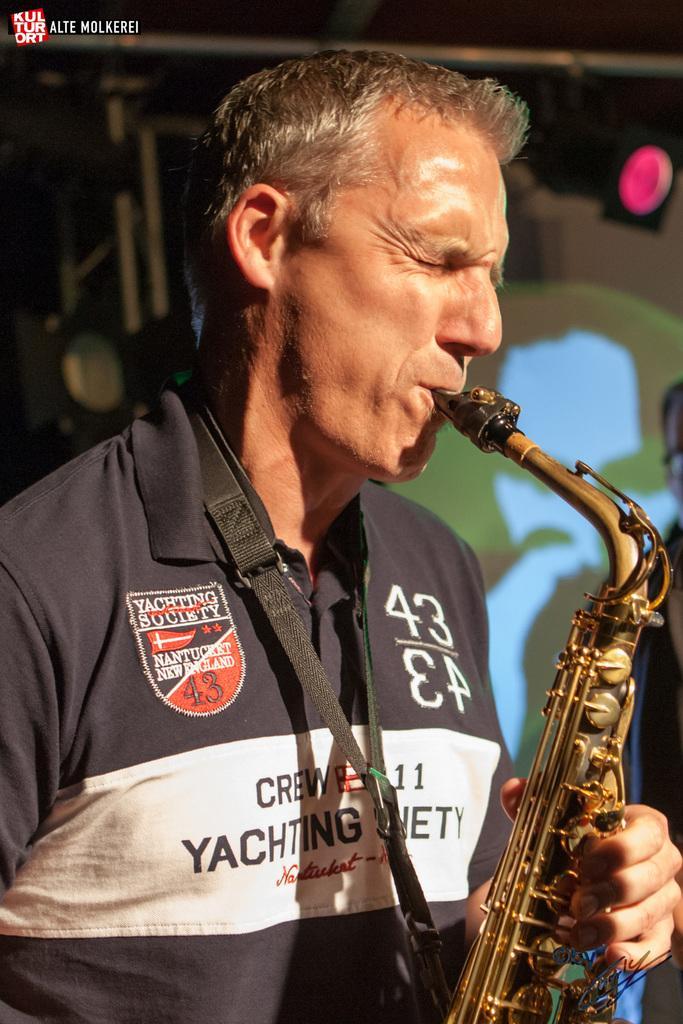How would you summarize this image in a sentence or two? In this image we can see a person standing and playing a musical instrument, in the background, we can see poles, light and the wall. 